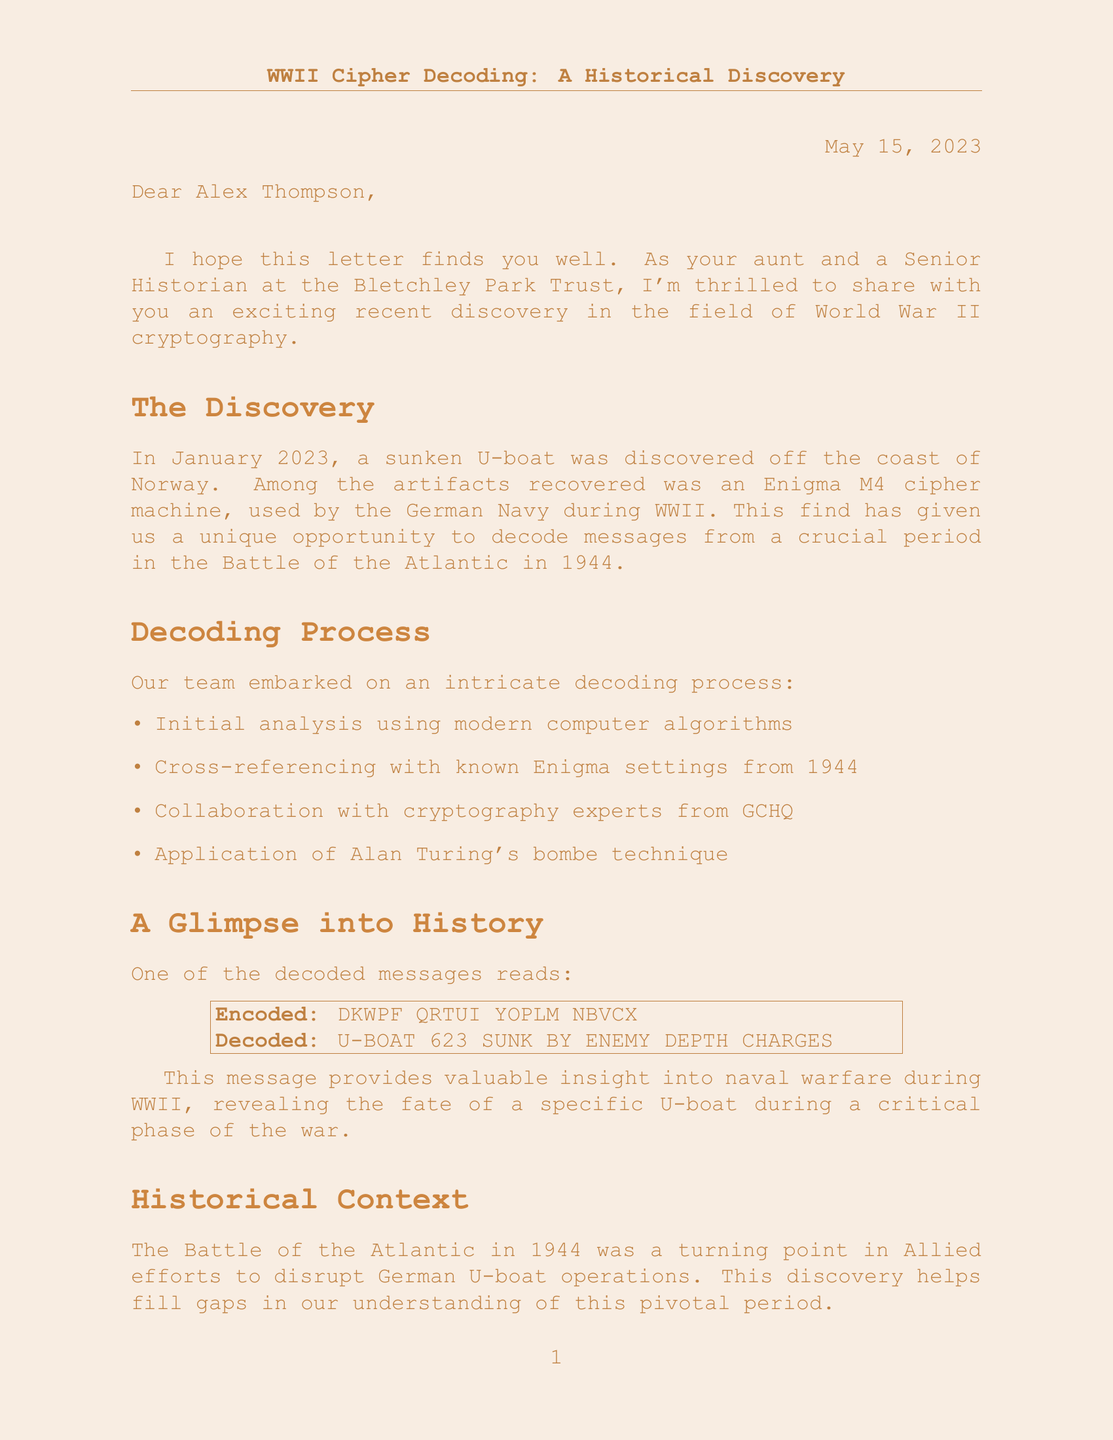What is the name of the historian who sent the letter? The historian who sent the letter is Dr. Elizabeth Harwood.
Answer: Dr. Elizabeth Harwood When was the letter written? The letter was written on May 15, 2023.
Answer: May 15, 2023 What was discovered in January 2023? In January 2023, a sunken U-boat was discovered.
Answer: A sunken U-boat What type of cipher was decoded? The type of cipher decoded was the Enigma M4.
Answer: Enigma M4 What battle is associated with the decoded message? The decoded message is associated with the Battle of the Atlantic.
Answer: Battle of the Atlantic How did the decoding team start the process? The decoding team started with initial analysis using modern computer algorithms.
Answer: Modern computer algorithms What was the fate of U-Boat 623 according to the decoded message? According to the decoded message, U-Boat 623 was sunk by enemy depth charges.
Answer: Sunk by enemy depth charges What year is mentioned in relation to the Battle of the Atlantic? The year mentioned in relation to the Battle of the Atlantic is 1944.
Answer: 1944 What does the personal note suggest about the decoding process? The personal note suggests that modern technology has helped unlock secrets from the past.
Answer: Modern technology has helped unlock secrets from the past 